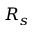Convert formula to latex. <formula><loc_0><loc_0><loc_500><loc_500>R _ { s }</formula> 